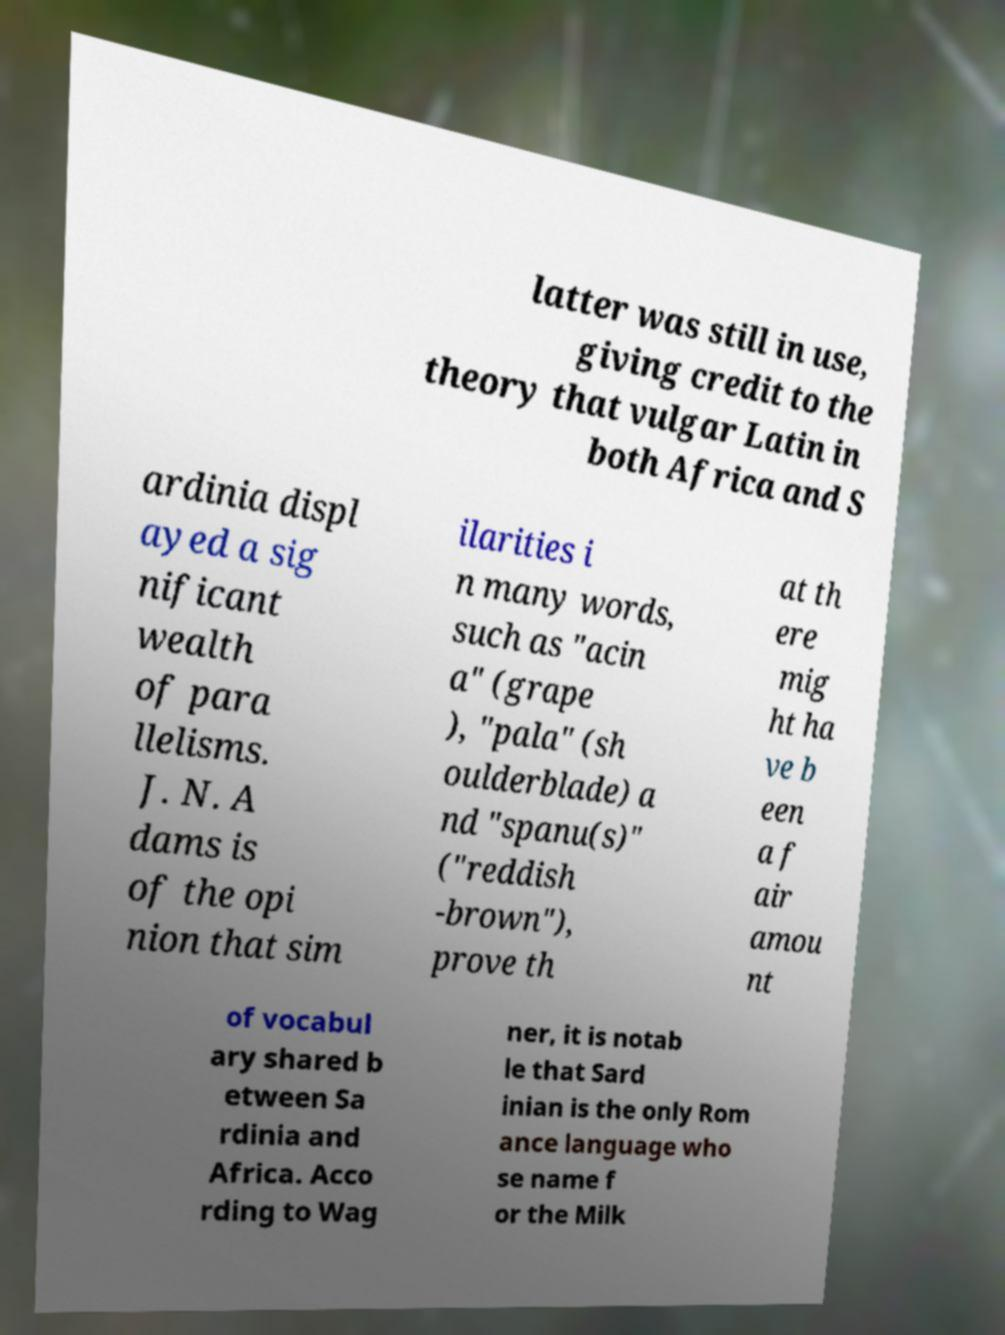What messages or text are displayed in this image? I need them in a readable, typed format. latter was still in use, giving credit to the theory that vulgar Latin in both Africa and S ardinia displ ayed a sig nificant wealth of para llelisms. J. N. A dams is of the opi nion that sim ilarities i n many words, such as "acin a" (grape ), "pala" (sh oulderblade) a nd "spanu(s)" ("reddish -brown"), prove th at th ere mig ht ha ve b een a f air amou nt of vocabul ary shared b etween Sa rdinia and Africa. Acco rding to Wag ner, it is notab le that Sard inian is the only Rom ance language who se name f or the Milk 